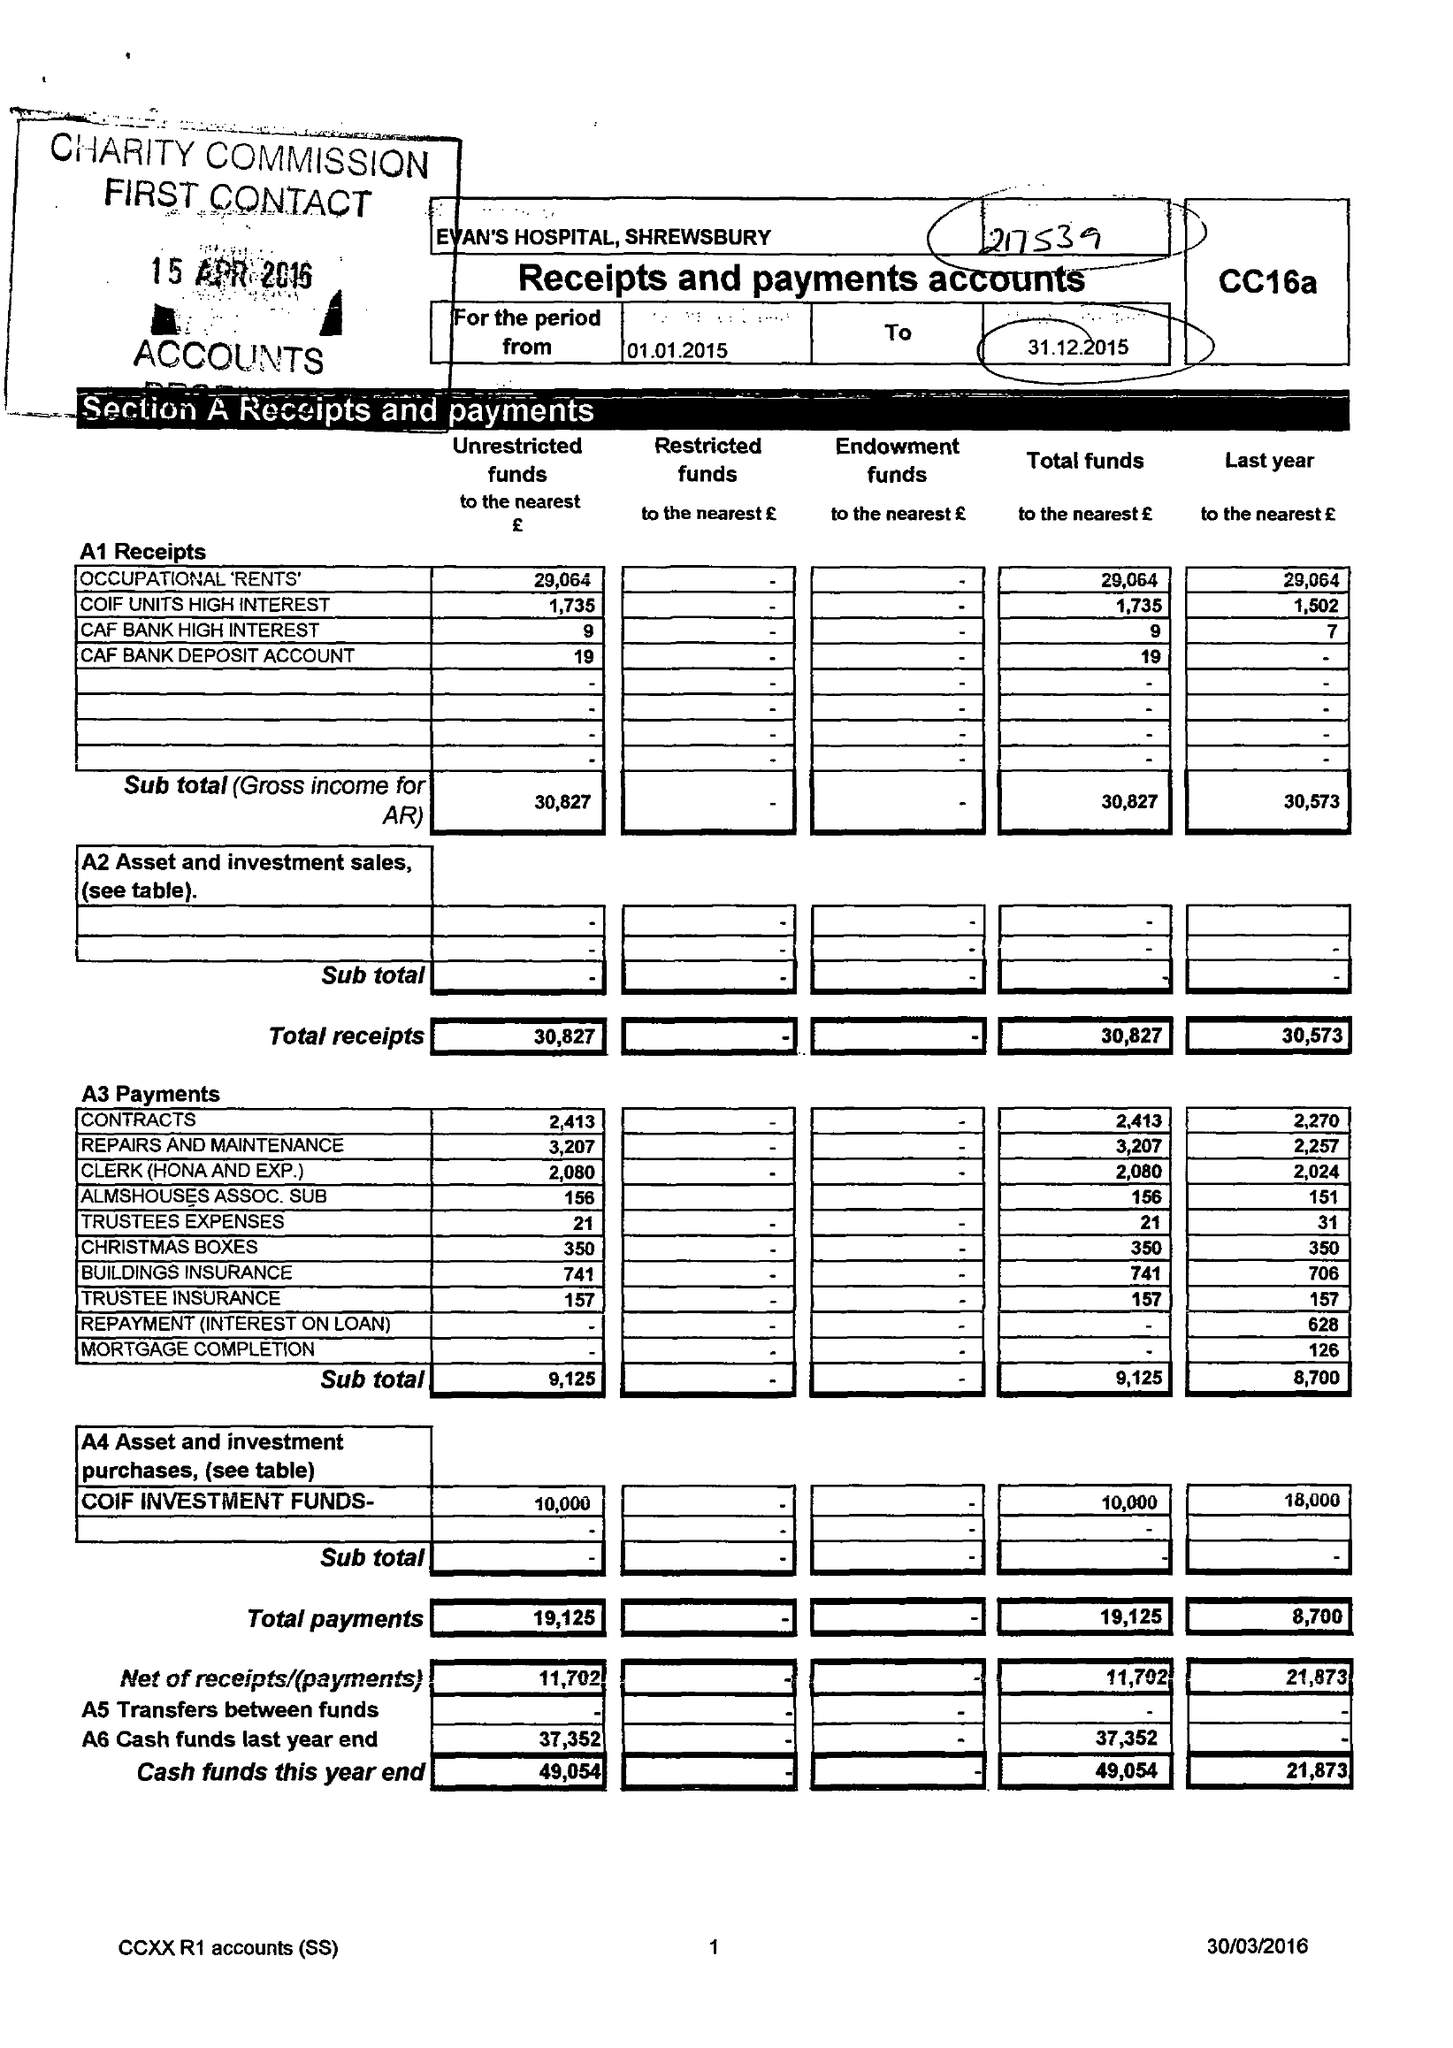What is the value for the address__street_line?
Answer the question using a single word or phrase. 63 ADSWOOD GROVE 